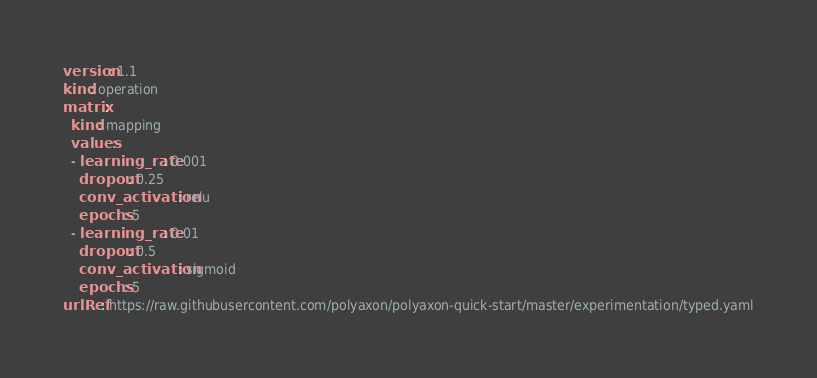<code> <loc_0><loc_0><loc_500><loc_500><_YAML_>version: 1.1
kind: operation
matrix:
  kind: mapping
  values:
  - learning_rate: 0.001
    dropout: 0.25
    conv_activation: relu
    epochs: 5
  - learning_rate: 0.01
    dropout: 0.5
    conv_activation: sigmoid
    epochs: 5
urlRef: https://raw.githubusercontent.com/polyaxon/polyaxon-quick-start/master/experimentation/typed.yaml
</code> 